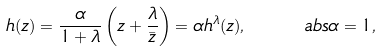<formula> <loc_0><loc_0><loc_500><loc_500>h ( z ) = \frac { \alpha } { 1 + \lambda } \left ( z + \frac { \lambda } { \bar { z } } \right ) = \alpha h ^ { \lambda } ( z ) , \quad \ a b s { \alpha } = 1 ,</formula> 